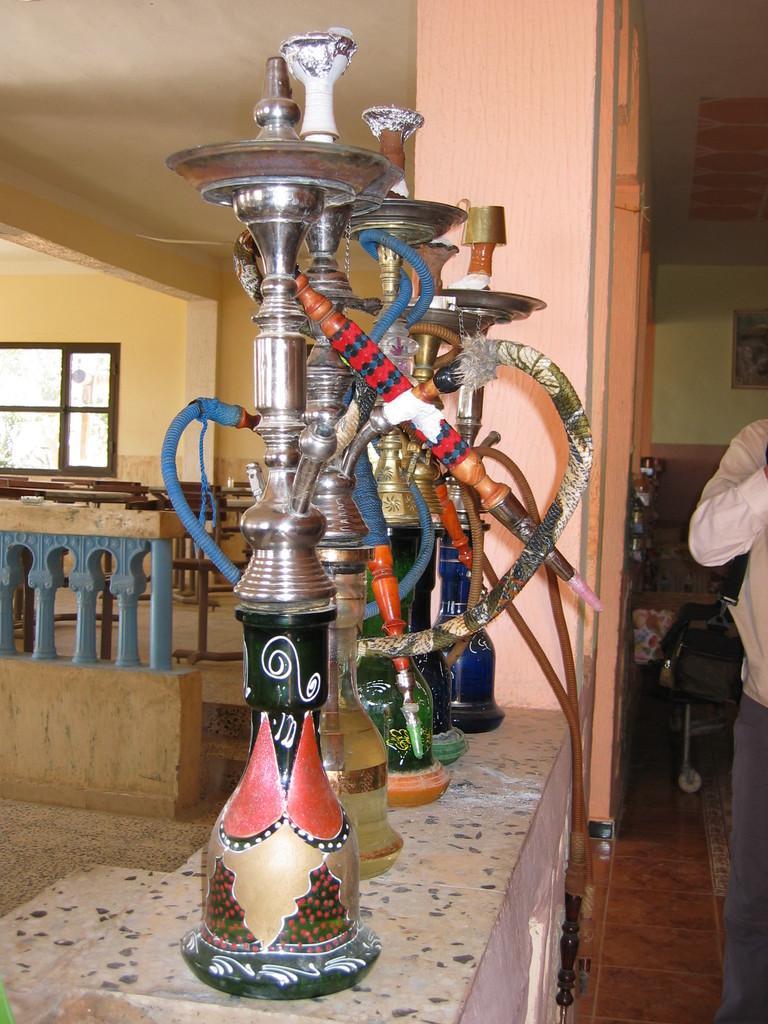Could you give a brief overview of what you see in this image? There is a person standing and we can see hookah pots. Background we can see wall and window. 